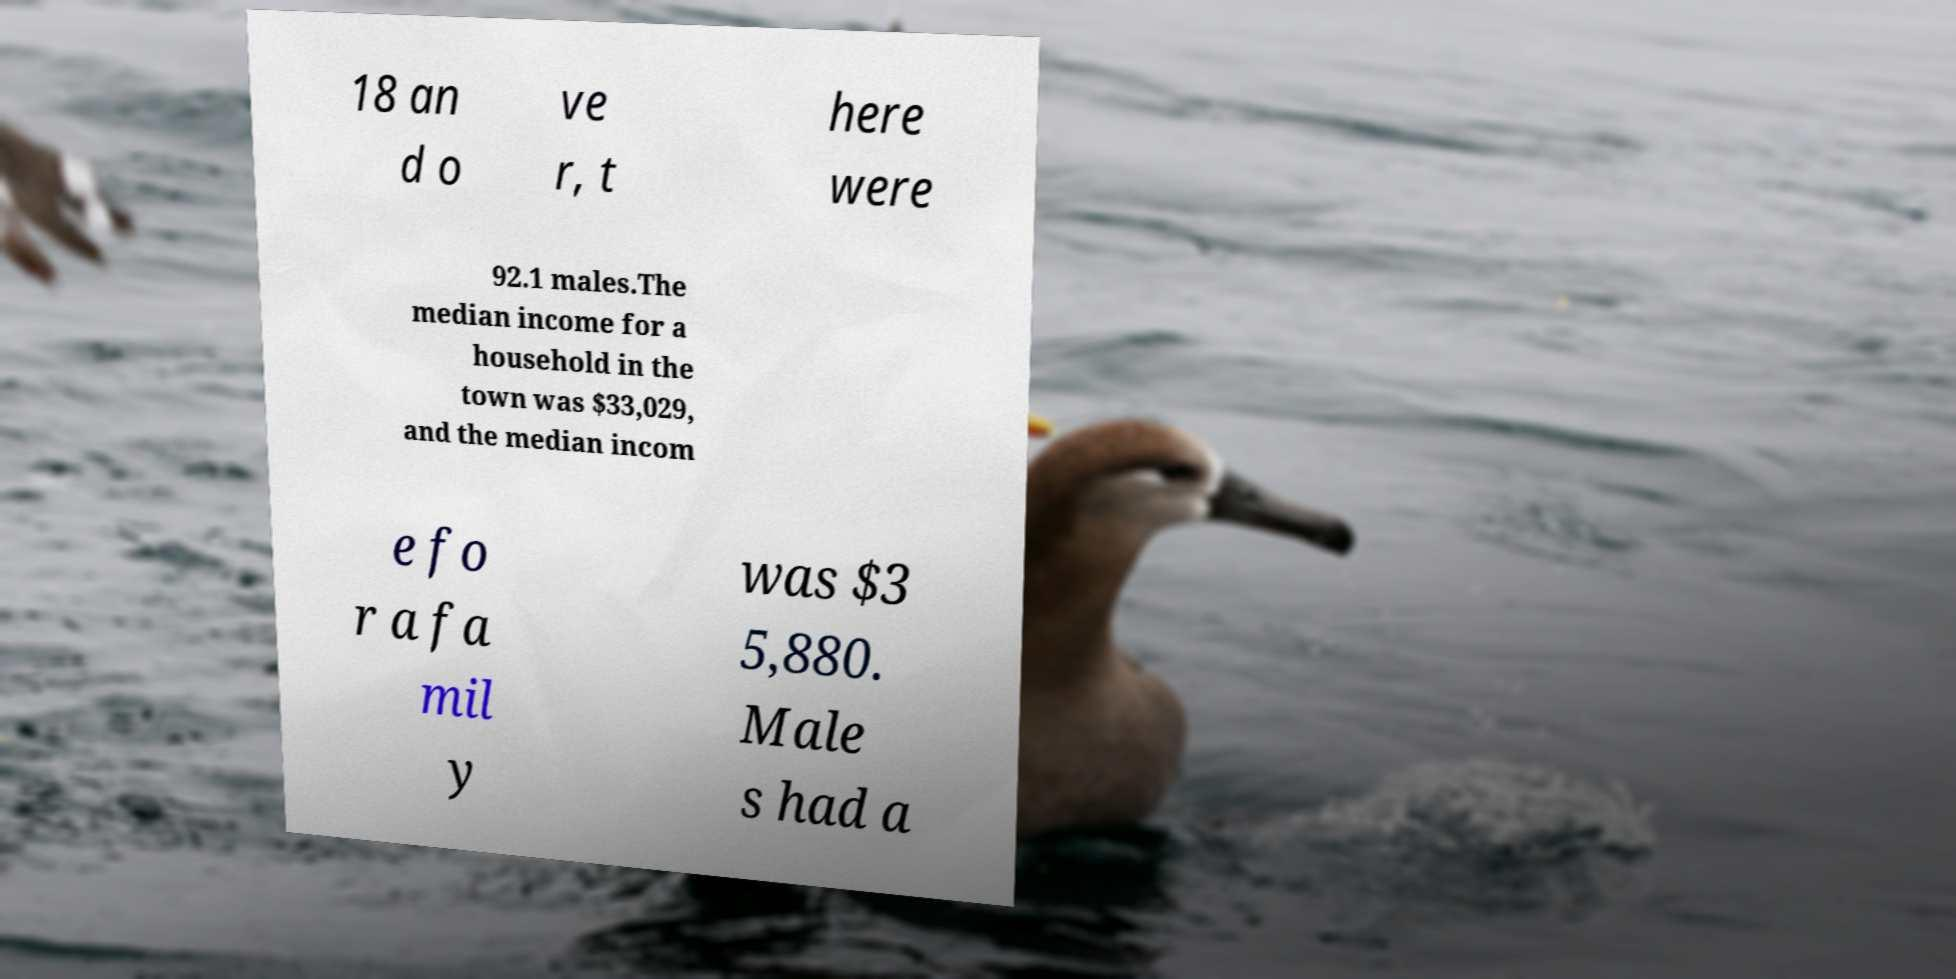I need the written content from this picture converted into text. Can you do that? 18 an d o ve r, t here were 92.1 males.The median income for a household in the town was $33,029, and the median incom e fo r a fa mil y was $3 5,880. Male s had a 